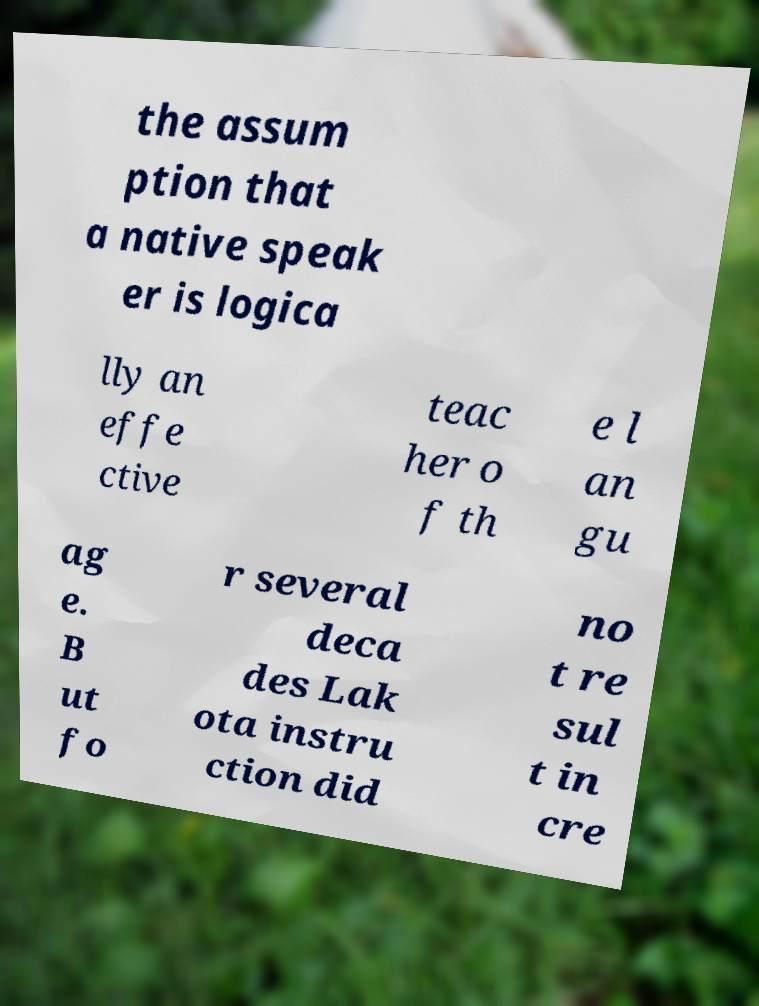Can you accurately transcribe the text from the provided image for me? the assum ption that a native speak er is logica lly an effe ctive teac her o f th e l an gu ag e. B ut fo r several deca des Lak ota instru ction did no t re sul t in cre 